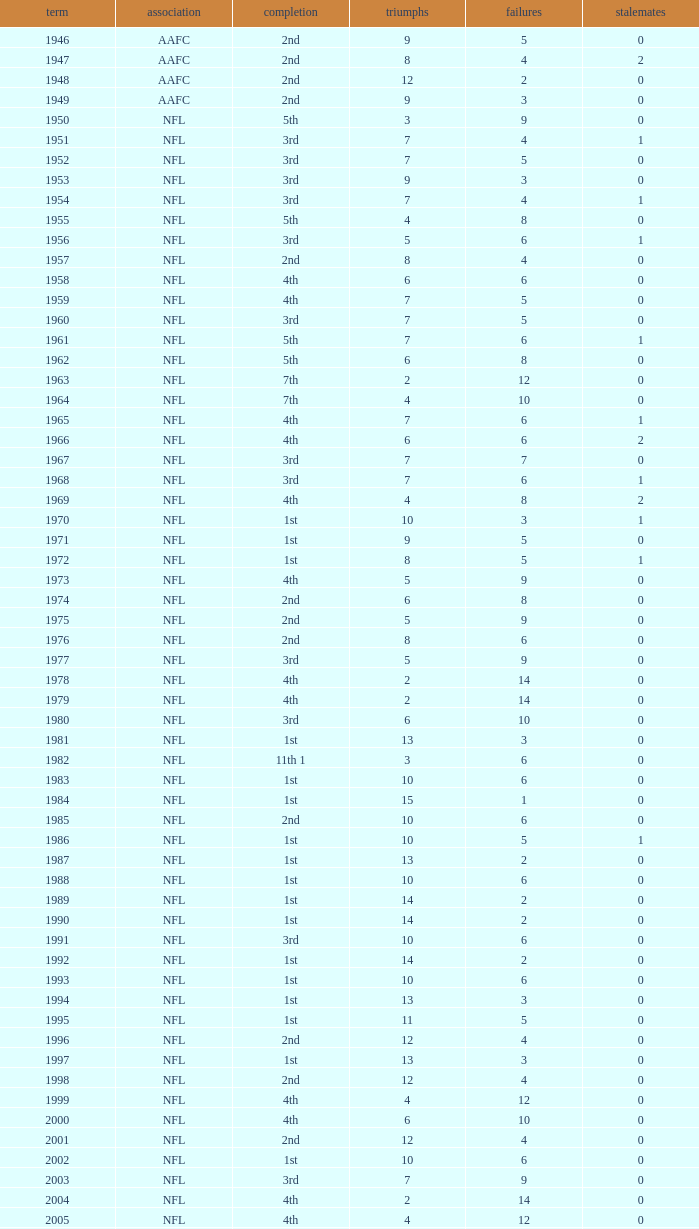What is the amount of losses when the ties are fewer than 0? 0.0. 